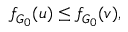<formula> <loc_0><loc_0><loc_500><loc_500>f _ { G _ { 0 } } ( u ) \leq f _ { G _ { 0 } } ( v ) ,</formula> 